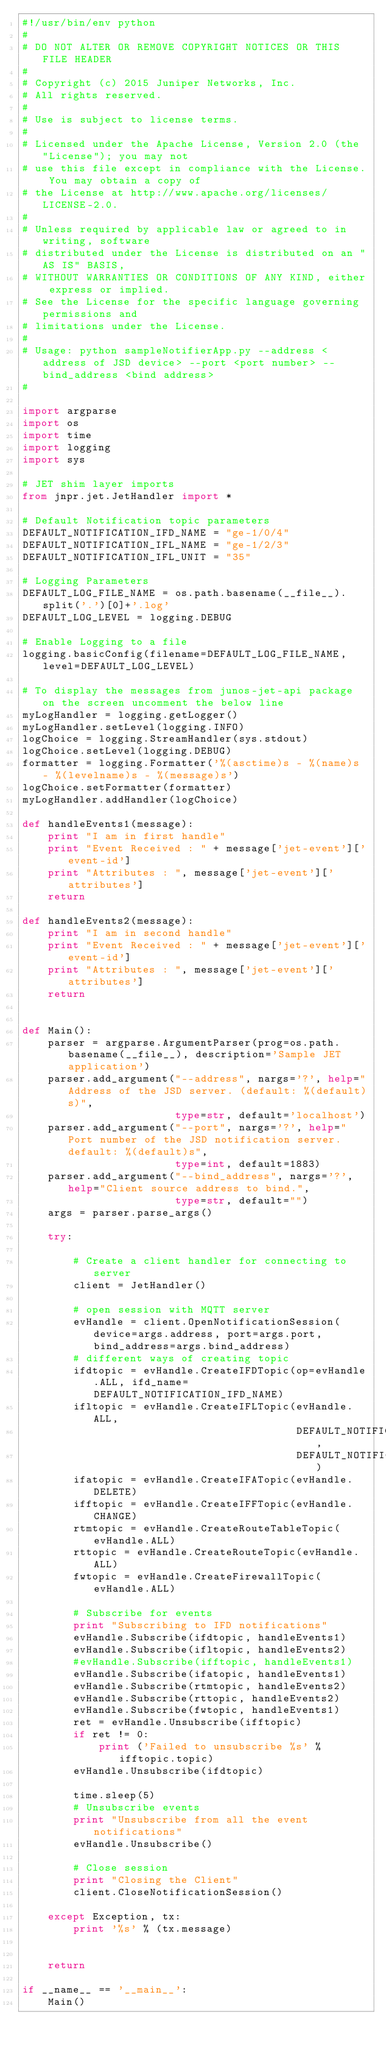<code> <loc_0><loc_0><loc_500><loc_500><_Python_>#!/usr/bin/env python
#
# DO NOT ALTER OR REMOVE COPYRIGHT NOTICES OR THIS FILE HEADER
#
# Copyright (c) 2015 Juniper Networks, Inc.
# All rights reserved.
#
# Use is subject to license terms.
#
# Licensed under the Apache License, Version 2.0 (the "License"); you may not
# use this file except in compliance with the License. You may obtain a copy of
# the License at http://www.apache.org/licenses/LICENSE-2.0.
#
# Unless required by applicable law or agreed to in writing, software
# distributed under the License is distributed on an "AS IS" BASIS,
# WITHOUT WARRANTIES OR CONDITIONS OF ANY KIND, either express or implied.
# See the License for the specific language governing permissions and
# limitations under the License.
#
# Usage: python sampleNotifierApp.py --address <address of JSD device> --port <port number> --bind_address <bind address>
#

import argparse
import os
import time
import logging
import sys

# JET shim layer imports
from jnpr.jet.JetHandler import *

# Default Notification topic parameters
DEFAULT_NOTIFICATION_IFD_NAME = "ge-1/0/4"
DEFAULT_NOTIFICATION_IFL_NAME = "ge-1/2/3"
DEFAULT_NOTIFICATION_IFL_UNIT = "35"

# Logging Parameters
DEFAULT_LOG_FILE_NAME = os.path.basename(__file__).split('.')[0]+'.log'
DEFAULT_LOG_LEVEL = logging.DEBUG

# Enable Logging to a file
logging.basicConfig(filename=DEFAULT_LOG_FILE_NAME, level=DEFAULT_LOG_LEVEL)

# To display the messages from junos-jet-api package on the screen uncomment the below line
myLogHandler = logging.getLogger()
myLogHandler.setLevel(logging.INFO)
logChoice = logging.StreamHandler(sys.stdout)
logChoice.setLevel(logging.DEBUG)
formatter = logging.Formatter('%(asctime)s - %(name)s - %(levelname)s - %(message)s')
logChoice.setFormatter(formatter)
myLogHandler.addHandler(logChoice)

def handleEvents1(message):
    print "I am in first handle"
    print "Event Received : " + message['jet-event']['event-id']
    print "Attributes : ", message['jet-event']['attributes']
    return

def handleEvents2(message):
    print "I am in second handle"
    print "Event Received : " + message['jet-event']['event-id']
    print "Attributes : ", message['jet-event']['attributes']
    return


def Main():
    parser = argparse.ArgumentParser(prog=os.path.basename(__file__), description='Sample JET application')
    parser.add_argument("--address", nargs='?', help="Address of the JSD server. (default: %(default)s)",
                        type=str, default='localhost')
    parser.add_argument("--port", nargs='?', help="Port number of the JSD notification server. default: %(default)s",
                        type=int, default=1883)
    parser.add_argument("--bind_address", nargs='?', help="Client source address to bind.",
                        type=str, default="")
    args = parser.parse_args()

    try:

        # Create a client handler for connecting to server
        client = JetHandler()

        # open session with MQTT server
        evHandle = client.OpenNotificationSession(device=args.address, port=args.port, bind_address=args.bind_address)
        # different ways of creating topic
        ifdtopic = evHandle.CreateIFDTopic(op=evHandle.ALL, ifd_name=DEFAULT_NOTIFICATION_IFD_NAME)
        ifltopic = evHandle.CreateIFLTopic(evHandle.ALL,
                                           DEFAULT_NOTIFICATION_IFL_NAME,
                                           DEFAULT_NOTIFICATION_IFL_UNIT)
        ifatopic = evHandle.CreateIFATopic(evHandle.DELETE)
        ifftopic = evHandle.CreateIFFTopic(evHandle.CHANGE)
        rtmtopic = evHandle.CreateRouteTableTopic(evHandle.ALL)
        rttopic = evHandle.CreateRouteTopic(evHandle.ALL)
        fwtopic = evHandle.CreateFirewallTopic(evHandle.ALL)

        # Subscribe for events
        print "Subscribing to IFD notifications"
        evHandle.Subscribe(ifdtopic, handleEvents1)
        evHandle.Subscribe(ifltopic, handleEvents2)
        #evHandle.Subscribe(ifftopic, handleEvents1)
        evHandle.Subscribe(ifatopic, handleEvents1)
        evHandle.Subscribe(rtmtopic, handleEvents2)
        evHandle.Subscribe(rttopic, handleEvents2)
        evHandle.Subscribe(fwtopic, handleEvents1)
        ret = evHandle.Unsubscribe(ifftopic)
        if ret != 0:
            print ('Failed to unsubscribe %s' %ifftopic.topic)
        evHandle.Unsubscribe(ifdtopic)

        time.sleep(5)
        # Unsubscribe events
        print "Unsubscribe from all the event notifications"
        evHandle.Unsubscribe()

        # Close session
        print "Closing the Client"
        client.CloseNotificationSession()

    except Exception, tx:
        print '%s' % (tx.message)


    return

if __name__ == '__main__':
    Main()
</code> 